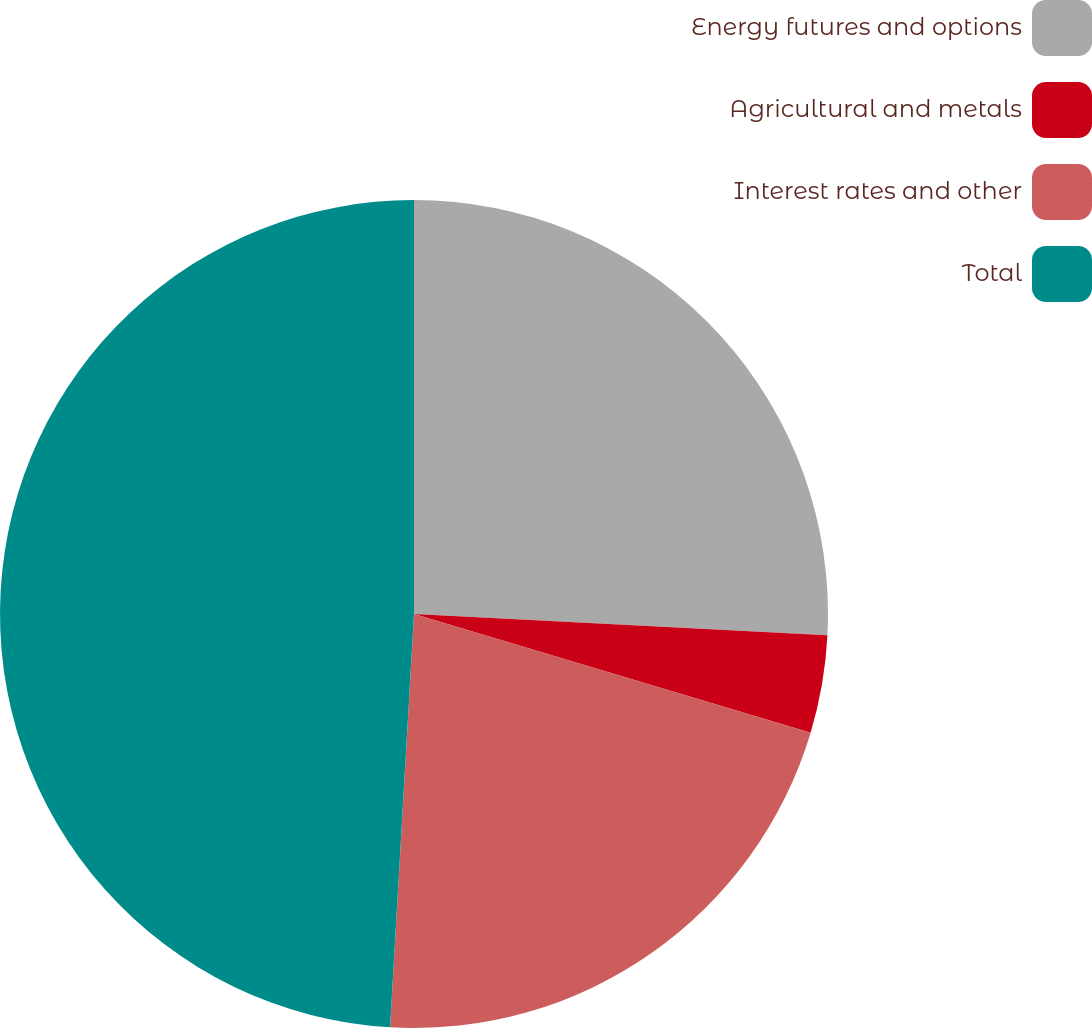<chart> <loc_0><loc_0><loc_500><loc_500><pie_chart><fcel>Energy futures and options<fcel>Agricultural and metals<fcel>Interest rates and other<fcel>Total<nl><fcel>25.82%<fcel>3.81%<fcel>21.29%<fcel>49.08%<nl></chart> 